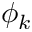Convert formula to latex. <formula><loc_0><loc_0><loc_500><loc_500>\phi _ { k }</formula> 